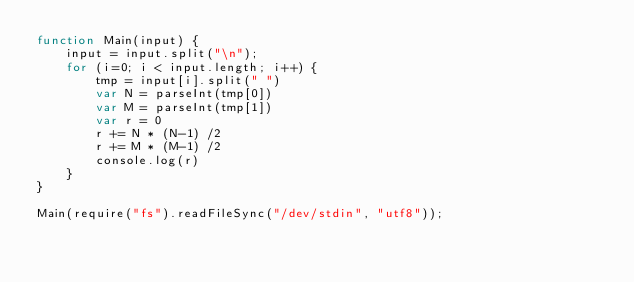Convert code to text. <code><loc_0><loc_0><loc_500><loc_500><_JavaScript_>function Main(input) {
    input = input.split("\n");
    for (i=0; i < input.length; i++) {
        tmp = input[i].split(" ")
        var N = parseInt(tmp[0])
        var M = parseInt(tmp[1])
        var r = 0
        r += N * (N-1) /2
        r += M * (M-1) /2
        console.log(r)
    }
}

Main(require("fs").readFileSync("/dev/stdin", "utf8"));
</code> 